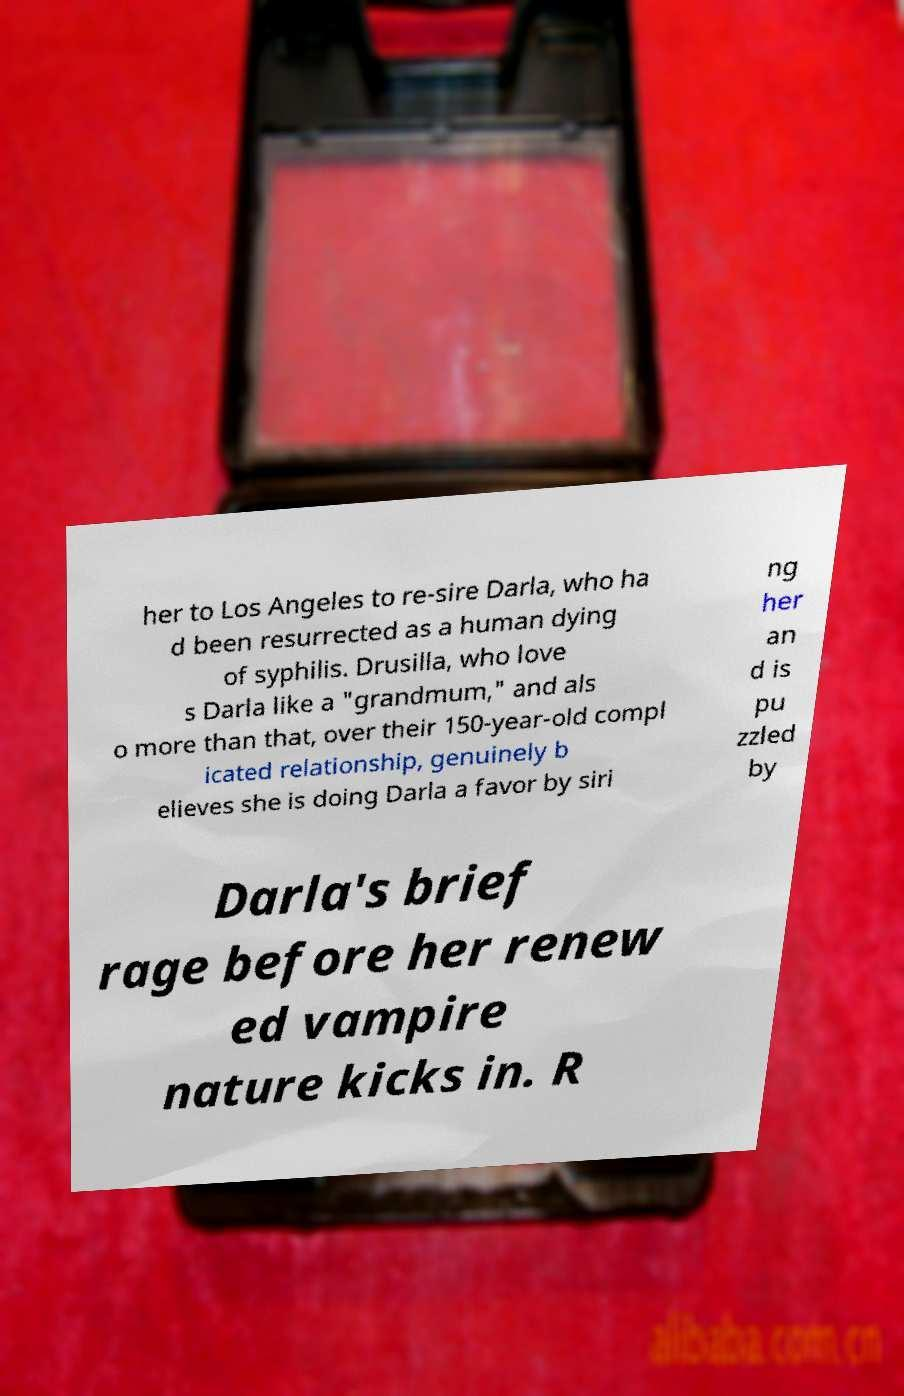Could you assist in decoding the text presented in this image and type it out clearly? her to Los Angeles to re-sire Darla, who ha d been resurrected as a human dying of syphilis. Drusilla, who love s Darla like a "grandmum," and als o more than that, over their 150-year-old compl icated relationship, genuinely b elieves she is doing Darla a favor by siri ng her an d is pu zzled by Darla's brief rage before her renew ed vampire nature kicks in. R 